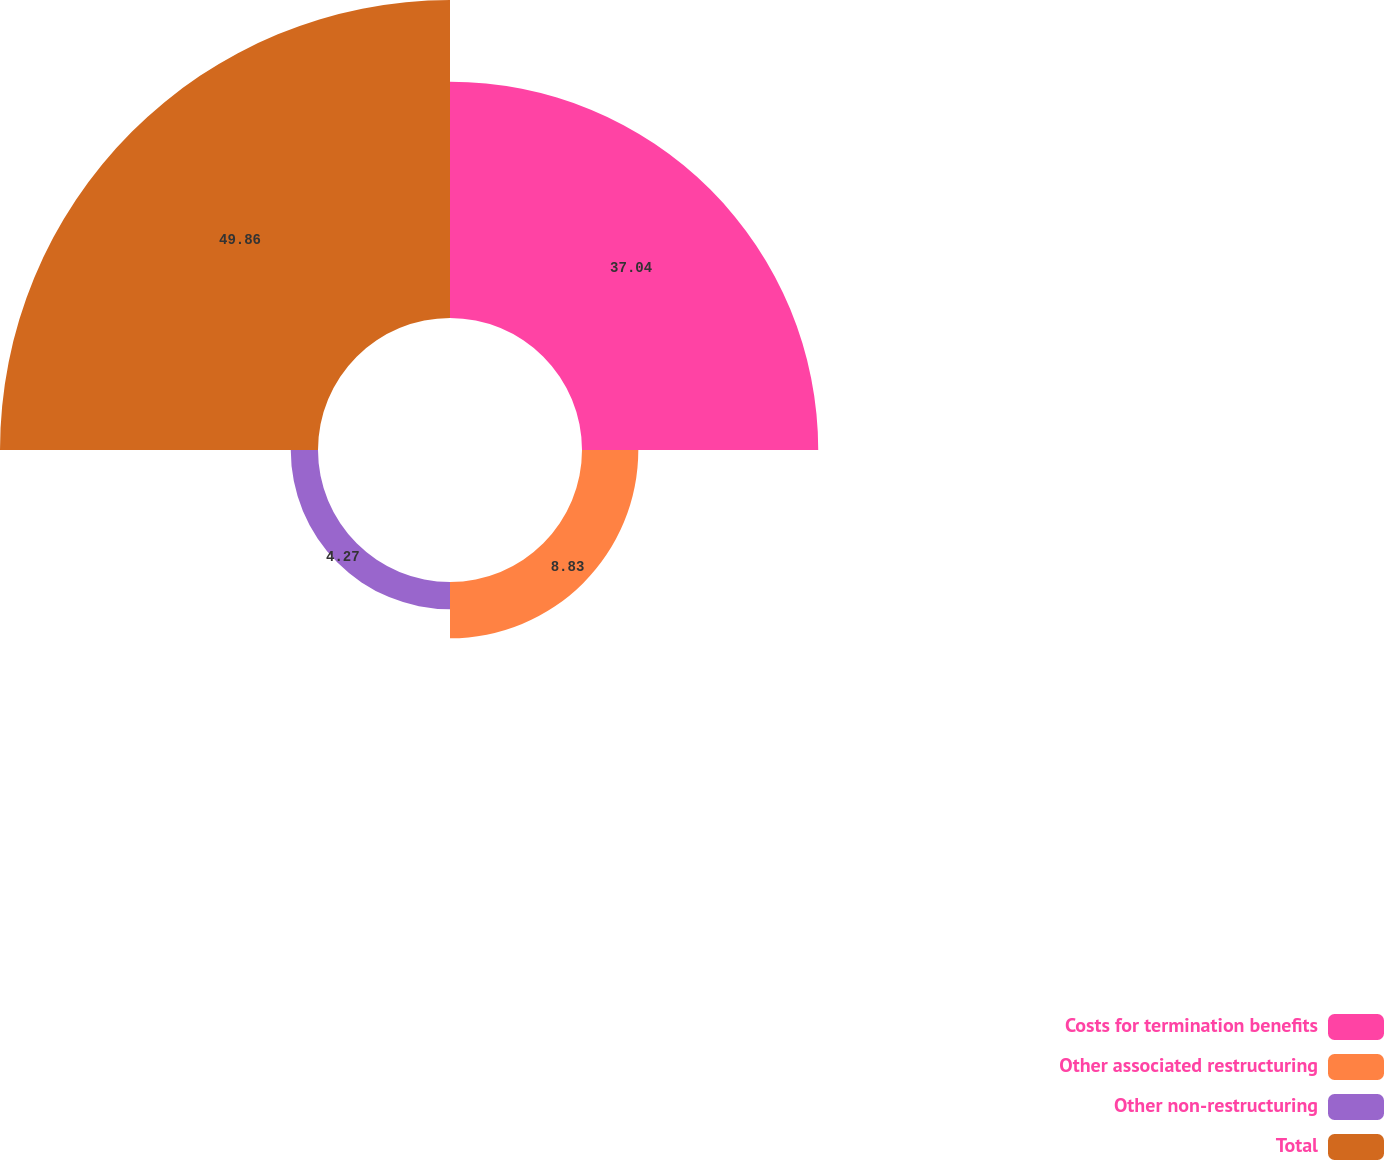Convert chart. <chart><loc_0><loc_0><loc_500><loc_500><pie_chart><fcel>Costs for termination benefits<fcel>Other associated restructuring<fcel>Other non-restructuring<fcel>Total<nl><fcel>37.04%<fcel>8.83%<fcel>4.27%<fcel>49.86%<nl></chart> 